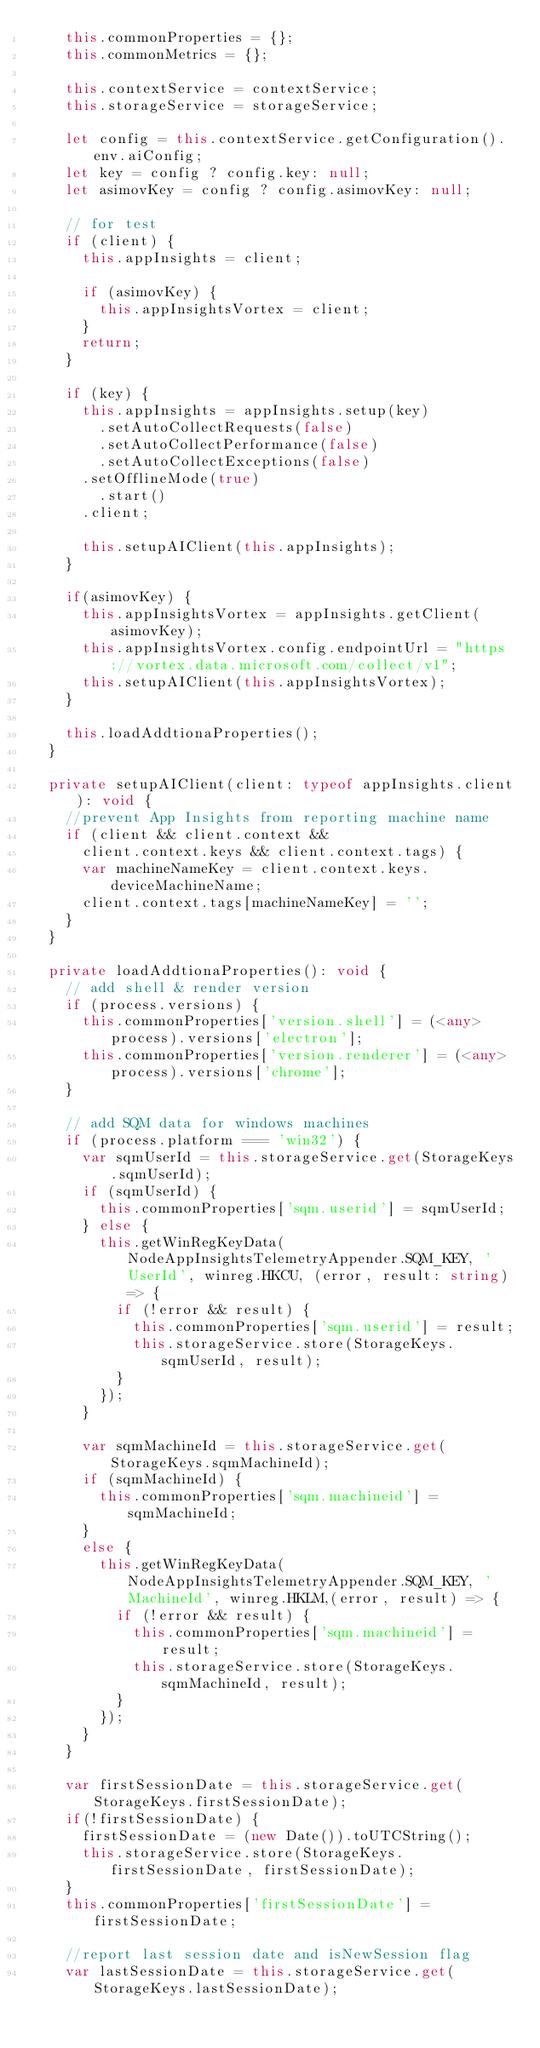<code> <loc_0><loc_0><loc_500><loc_500><_TypeScript_>		this.commonProperties = {};
		this.commonMetrics = {};

		this.contextService = contextService;
		this.storageService = storageService;

		let config = this.contextService.getConfiguration().env.aiConfig;
		let key = config ? config.key: null;
		let asimovKey = config ? config.asimovKey: null;

		// for test
		if (client) {
			this.appInsights = client;

			if (asimovKey) {
				this.appInsightsVortex = client;
			}
			return;
		}

		if (key) {
			this.appInsights = appInsights.setup(key)
		    .setAutoCollectRequests(false)
		    .setAutoCollectPerformance(false)
		    .setAutoCollectExceptions(false)
			.setOfflineMode(true)
		    .start()
			.client;

			this.setupAIClient(this.appInsights);
		}

		if(asimovKey) {
			this.appInsightsVortex = appInsights.getClient(asimovKey);
			this.appInsightsVortex.config.endpointUrl = "https://vortex.data.microsoft.com/collect/v1";
			this.setupAIClient(this.appInsightsVortex);
		}

		this.loadAddtionaProperties();
	}

	private setupAIClient(client: typeof appInsights.client): void {
		//prevent App Insights from reporting machine name
		if (client && client.context &&
			client.context.keys && client.context.tags) {
			var machineNameKey = client.context.keys.deviceMachineName;
		 	client.context.tags[machineNameKey] = '';
		}
	}

	private loadAddtionaProperties(): void {
		// add shell & render version
		if (process.versions) {
			this.commonProperties['version.shell'] = (<any>process).versions['electron'];
			this.commonProperties['version.renderer'] = (<any>process).versions['chrome'];
		}

		// add SQM data for windows machines
		if (process.platform === 'win32') {
			var sqmUserId = this.storageService.get(StorageKeys.sqmUserId);
			if (sqmUserId) {
				this.commonProperties['sqm.userid'] = sqmUserId;
			} else {
				this.getWinRegKeyData(NodeAppInsightsTelemetryAppender.SQM_KEY, 'UserId', winreg.HKCU, (error, result: string) => {
					if (!error && result) {
						this.commonProperties['sqm.userid'] = result;
						this.storageService.store(StorageKeys.sqmUserId, result);
					}
				});
			}

			var sqmMachineId = this.storageService.get(StorageKeys.sqmMachineId);
			if (sqmMachineId) {
				this.commonProperties['sqm.machineid'] = sqmMachineId;
			}
			else {
				this.getWinRegKeyData(NodeAppInsightsTelemetryAppender.SQM_KEY, 'MachineId', winreg.HKLM,(error, result) => {
					if (!error && result) {
						this.commonProperties['sqm.machineid'] = result;
						this.storageService.store(StorageKeys.sqmMachineId, result);
					}
				});
			}
		}

		var firstSessionDate = this.storageService.get(StorageKeys.firstSessionDate);
		if(!firstSessionDate) {
			firstSessionDate = (new Date()).toUTCString();
			this.storageService.store(StorageKeys.firstSessionDate, firstSessionDate);
		}
		this.commonProperties['firstSessionDate'] = firstSessionDate;

		//report last session date and isNewSession flag
		var lastSessionDate = this.storageService.get(StorageKeys.lastSessionDate);</code> 